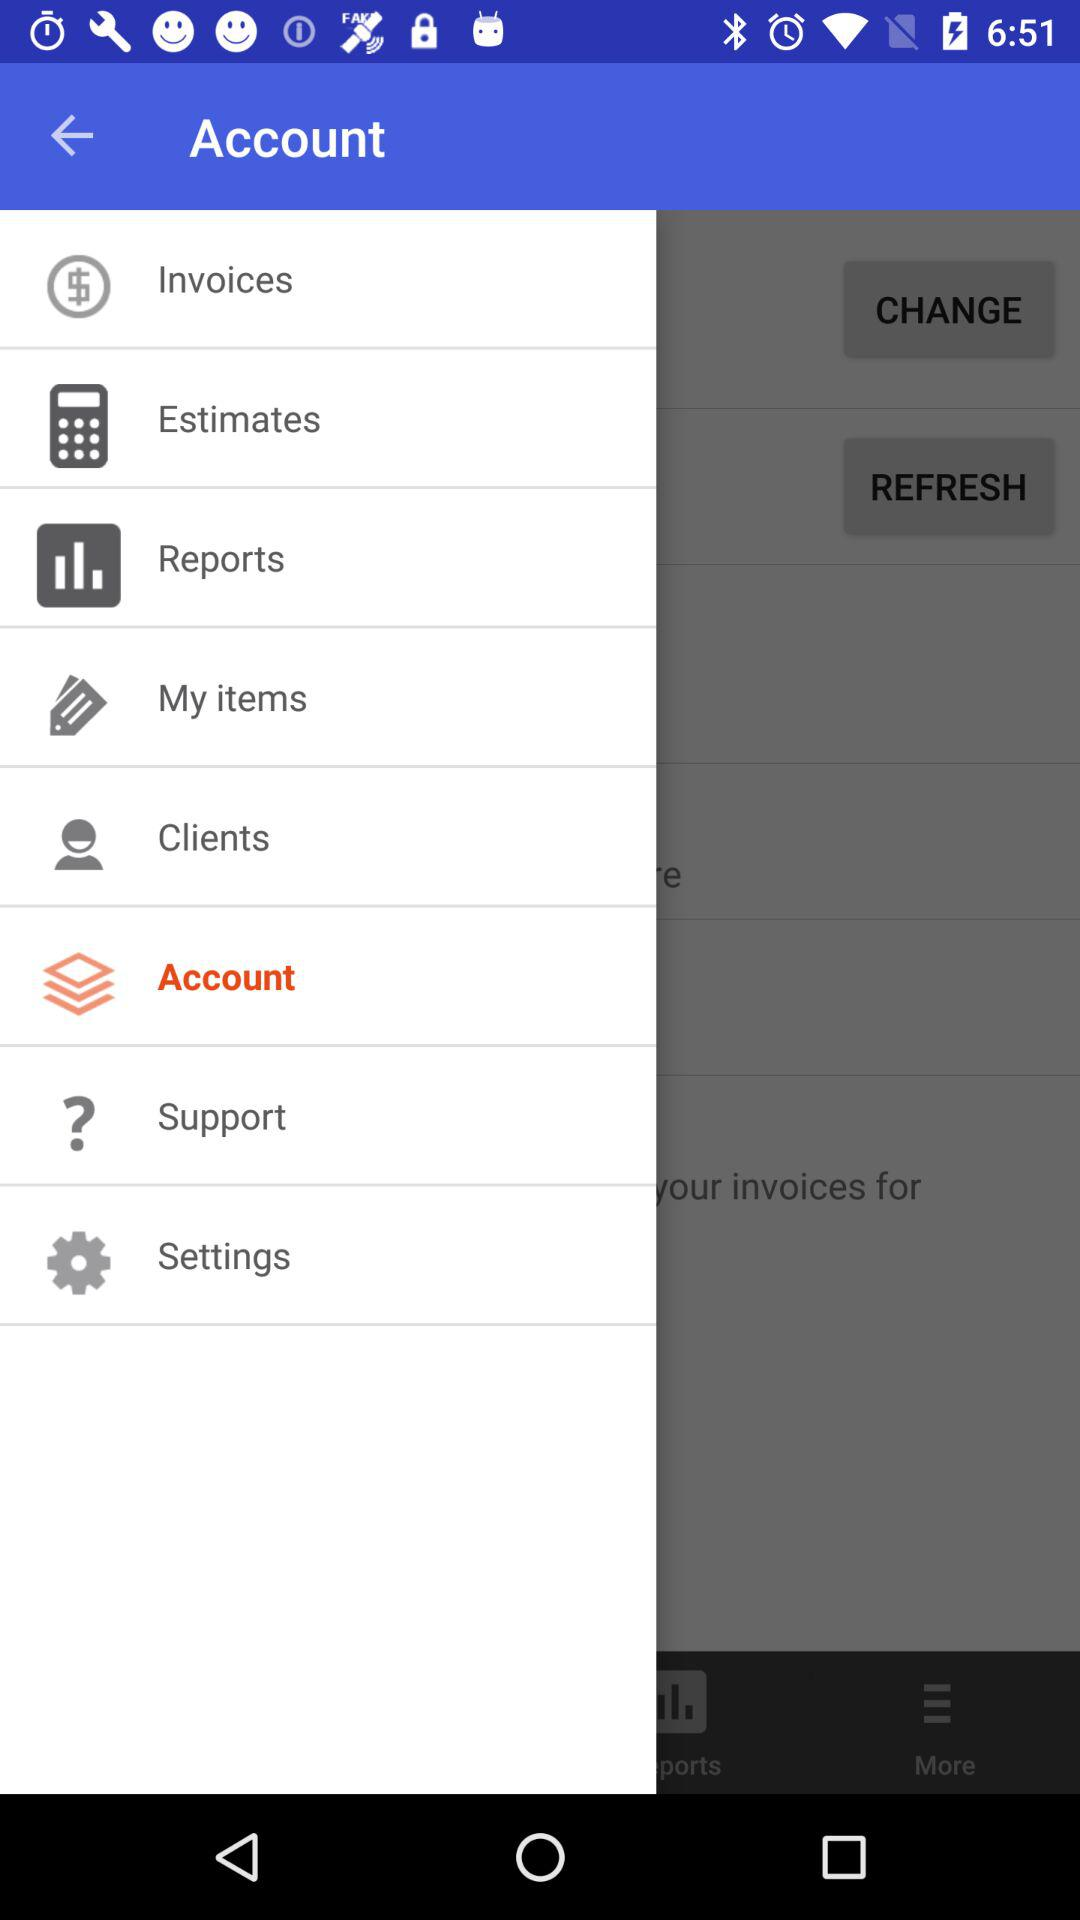Which tab has been selected? The selected tab is "Account". 